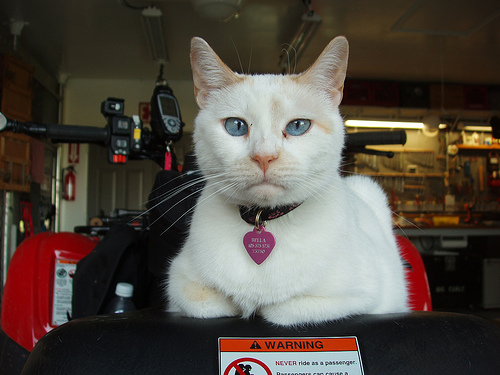<image>
Is the cat on the motorbike? Yes. Looking at the image, I can see the cat is positioned on top of the motorbike, with the motorbike providing support. 